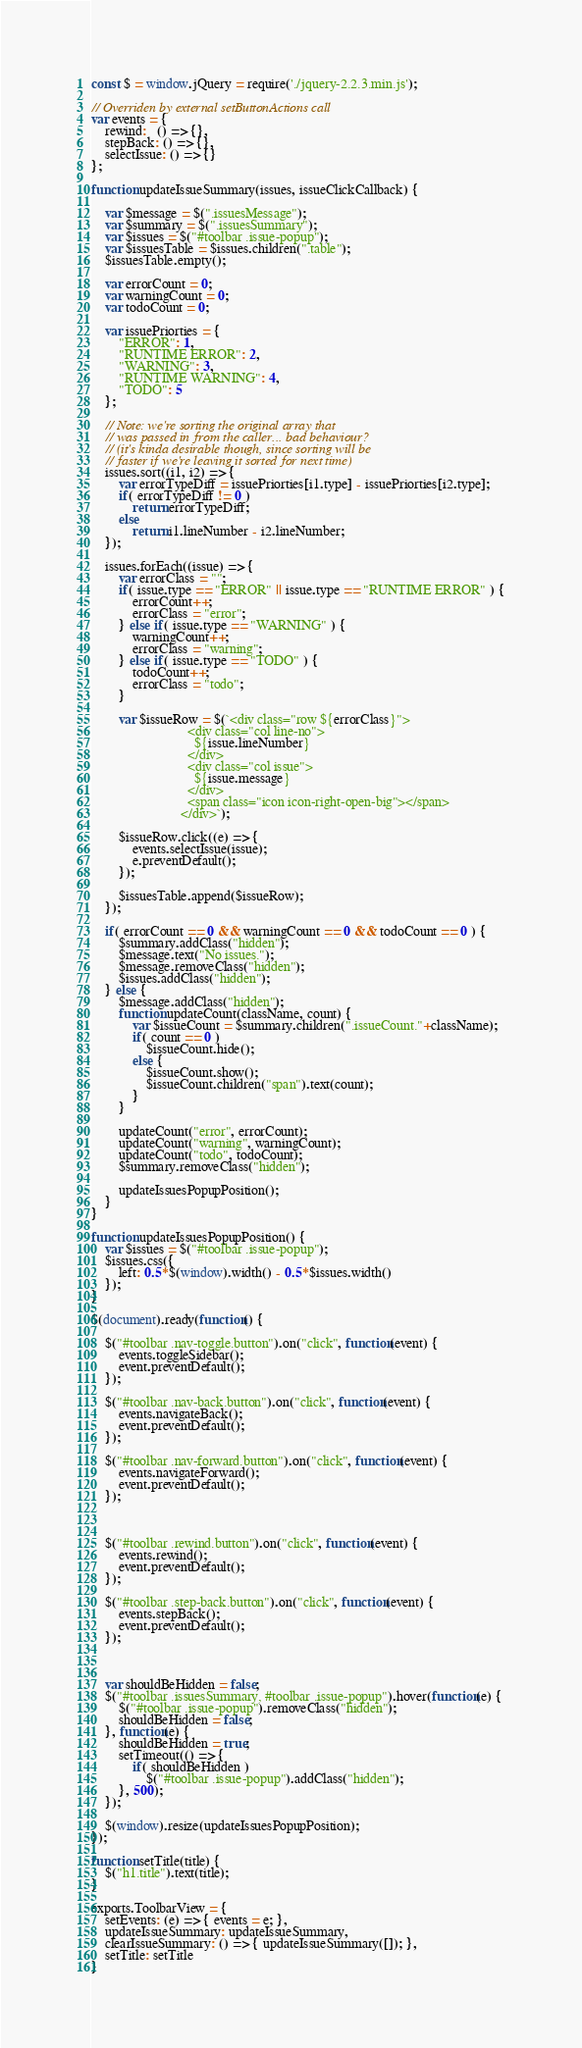Convert code to text. <code><loc_0><loc_0><loc_500><loc_500><_JavaScript_>const $ = window.jQuery = require('./jquery-2.2.3.min.js');

// Overriden by external setButtonActions call
var events = {
    rewind:   () => {},
    stepBack: () => {},
    selectIssue: () => {}
};

function updateIssueSummary(issues, issueClickCallback) {

    var $message = $(".issuesMessage");
    var $summary = $(".issuesSummary");
    var $issues = $("#toolbar .issue-popup");
    var $issuesTable = $issues.children(".table");
    $issuesTable.empty();

    var errorCount = 0;
    var warningCount = 0;
    var todoCount = 0;

    var issuePriorties = {
        "ERROR": 1,
        "RUNTIME ERROR": 2,
        "WARNING": 3,
        "RUNTIME WARNING": 4,
        "TODO": 5
    };

    // Note: we're sorting the original array that 
    // was passed in from the caller... bad behaviour?
    // (it's kinda desirable though, since sorting will be
    // faster if we're leaving it sorted for next time)
    issues.sort((i1, i2) => {
        var errorTypeDiff = issuePriorties[i1.type] - issuePriorties[i2.type];
        if( errorTypeDiff != 0 )
            return errorTypeDiff;
        else
            return i1.lineNumber - i2.lineNumber;
    });

    issues.forEach((issue) => {
        var errorClass = "";
        if( issue.type == "ERROR" || issue.type == "RUNTIME ERROR" ) {
            errorCount++;
            errorClass = "error";
        } else if( issue.type == "WARNING" ) {
            warningCount++;
            errorClass = "warning";
        } else if( issue.type == "TODO" ) {
            todoCount++;
            errorClass = "todo";
        }

        var $issueRow = $(`<div class="row ${errorClass}">
                            <div class="col line-no">
                              ${issue.lineNumber}
                            </div>
                            <div class="col issue">
                              ${issue.message}
                            </div>
                            <span class="icon icon-right-open-big"></span>
                          </div>`);

        $issueRow.click((e) => {
            events.selectIssue(issue);
            e.preventDefault();
        });

        $issuesTable.append($issueRow);
    });

    if( errorCount == 0 && warningCount == 0 && todoCount == 0 ) {
        $summary.addClass("hidden");
        $message.text("No issues.");
        $message.removeClass("hidden");
        $issues.addClass("hidden");
    } else {
        $message.addClass("hidden");
        function updateCount(className, count) {
            var $issueCount = $summary.children(".issueCount."+className);
            if( count == 0 )
                $issueCount.hide();
            else {
                $issueCount.show();
                $issueCount.children("span").text(count);
            }
        }

        updateCount("error", errorCount);
        updateCount("warning", warningCount);
        updateCount("todo", todoCount);
        $summary.removeClass("hidden");

        updateIssuesPopupPosition();
    }
}

function updateIssuesPopupPosition() {
    var $issues = $("#toolbar .issue-popup");
    $issues.css({
        left: 0.5*$(window).width() - 0.5*$issues.width()
    });
}

$(document).ready(function() {

    $("#toolbar .nav-toggle.button").on("click", function(event) {
        events.toggleSidebar();
        event.preventDefault();
    });

    $("#toolbar .nav-back.button").on("click", function(event) {
        events.navigateBack();
        event.preventDefault();
    });

    $("#toolbar .nav-forward.button").on("click", function(event) {
        events.navigateForward();
        event.preventDefault();
    });



    $("#toolbar .rewind.button").on("click", function(event) {
        events.rewind();
        event.preventDefault();
    });

    $("#toolbar .step-back.button").on("click", function(event) {
        events.stepBack();
        event.preventDefault();
    });

    

    var shouldBeHidden = false;
    $("#toolbar .issuesSummary, #toolbar .issue-popup").hover(function(e) {
        $("#toolbar .issue-popup").removeClass("hidden");
        shouldBeHidden = false;
    }, function(e) {
        shouldBeHidden = true;
        setTimeout(() => { 
            if( shouldBeHidden )
                $("#toolbar .issue-popup").addClass("hidden");
        }, 500);
    });

    $(window).resize(updateIssuesPopupPosition);
});

function setTitle(title) {
    $("h1.title").text(title);
}

exports.ToolbarView = {
    setEvents: (e) => { events = e; },
    updateIssueSummary: updateIssueSummary,
    clearIssueSummary: () => { updateIssueSummary([]); },
    setTitle: setTitle
}</code> 